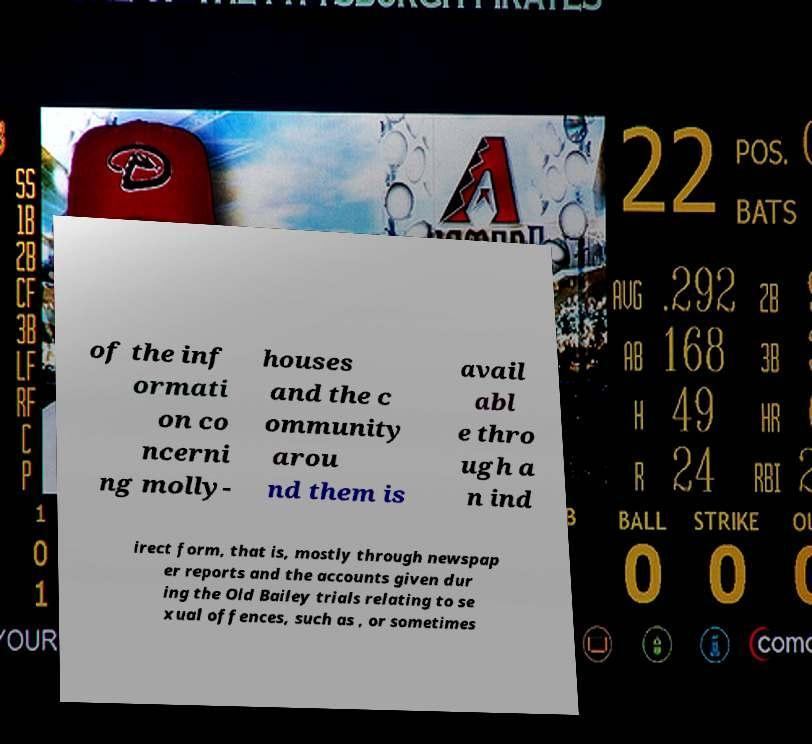Can you accurately transcribe the text from the provided image for me? of the inf ormati on co ncerni ng molly- houses and the c ommunity arou nd them is avail abl e thro ugh a n ind irect form, that is, mostly through newspap er reports and the accounts given dur ing the Old Bailey trials relating to se xual offences, such as , or sometimes 